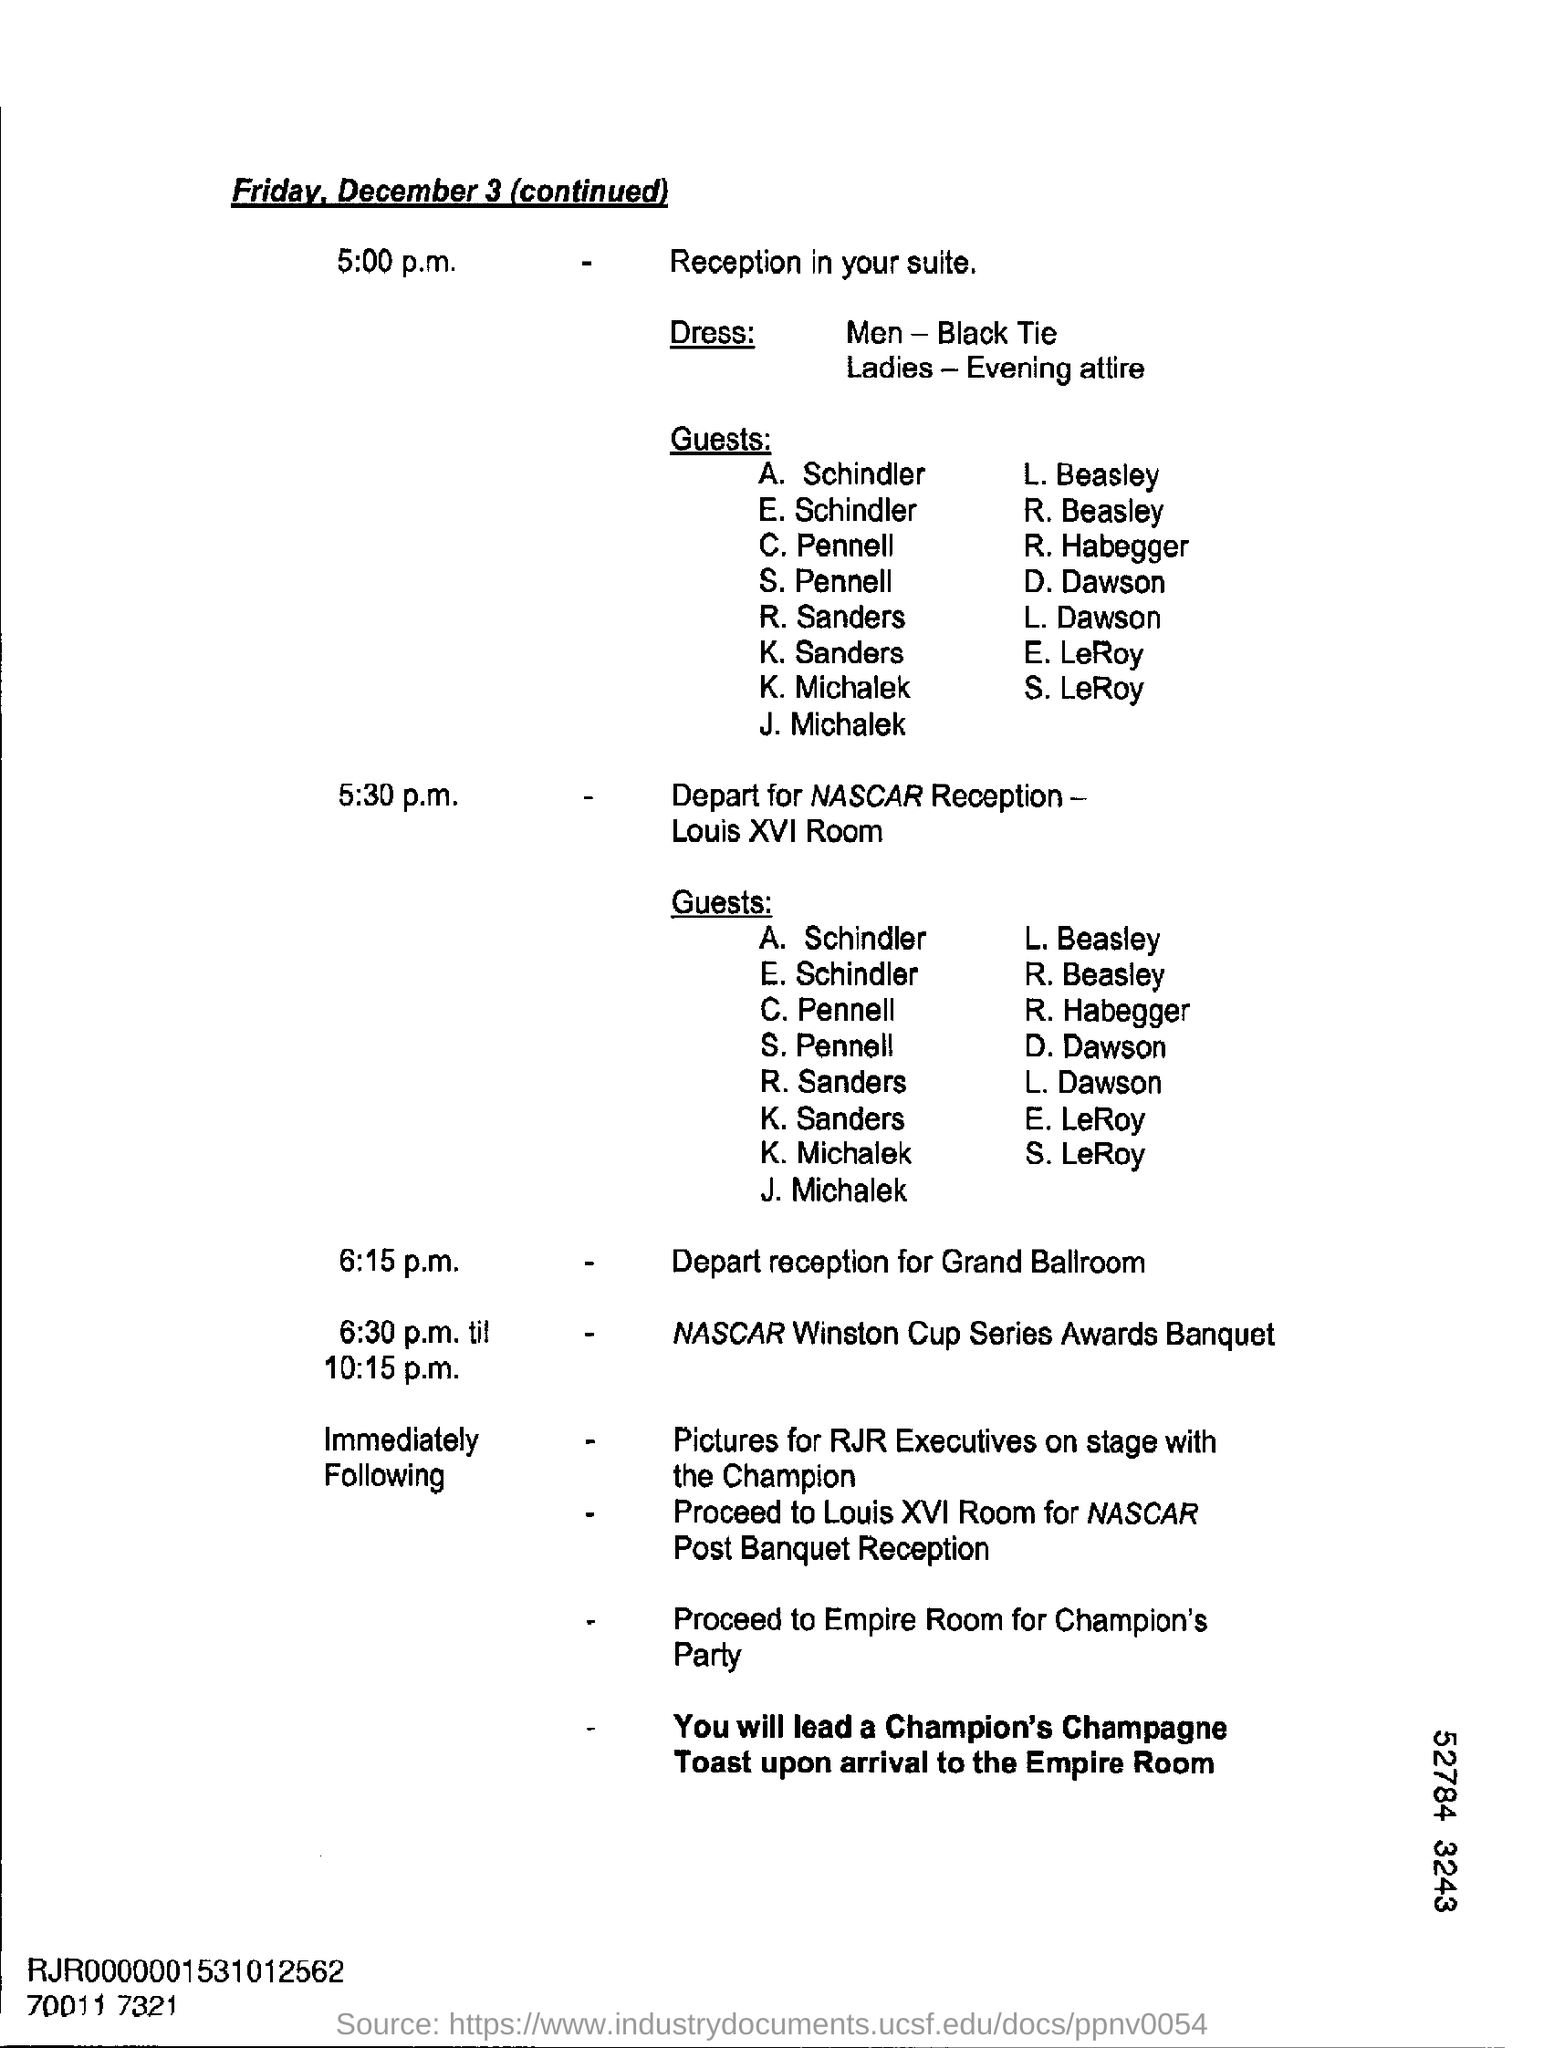Highlight a few significant elements in this photo. On December 3, Friday will occur. Your suite's reception is scheduled for 5:00 PM. The dress code for men is black tie. The reception for the grand ballroom is scheduled to take place at 6:15 p.m. 